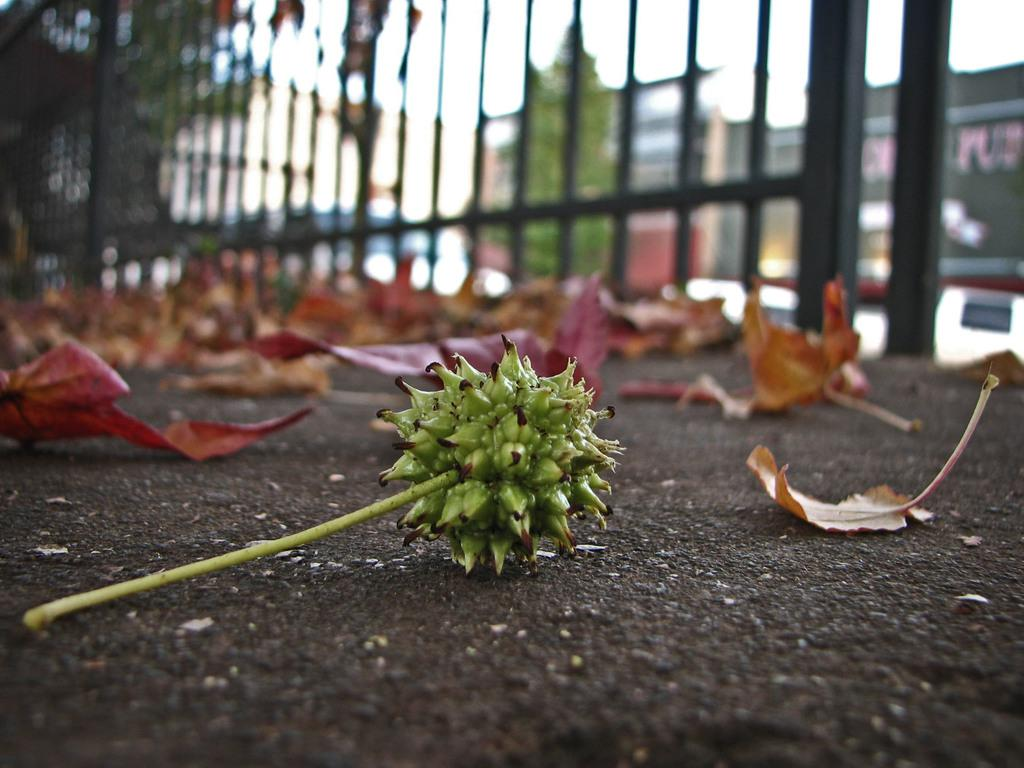What is on the ground in the image? There are leaves and a stem with a flower on the ground in the image. What can be seen in the background of the image? There are trees, buildings, and some unspecified objects in the background of the image. Can you describe the fence in the image? The provided facts do not mention a fence in the image. How is the background of the image depicted? The background of the image is blurry. What is the silver wishing well in the image used for? There is no silver wishing well present in the image. Can you point out the location of the pointy object in the image? There is no mention of a pointy object in the image. 